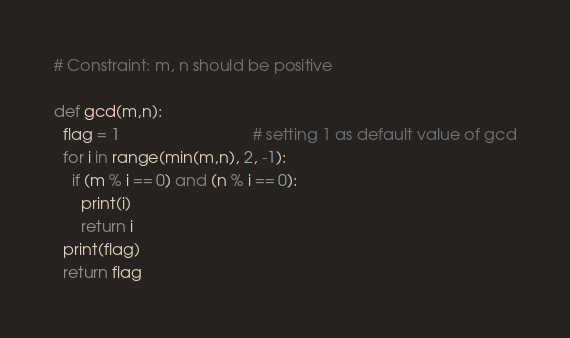Convert code to text. <code><loc_0><loc_0><loc_500><loc_500><_Python_># Constraint: m, n should be positive

def gcd(m,n):
  flag = 1                              # setting 1 as default value of gcd
  for i in range(min(m,n), 2, -1):
    if (m % i == 0) and (n % i == 0):
      print(i)
      return i
  print(flag)
  return flag
</code> 